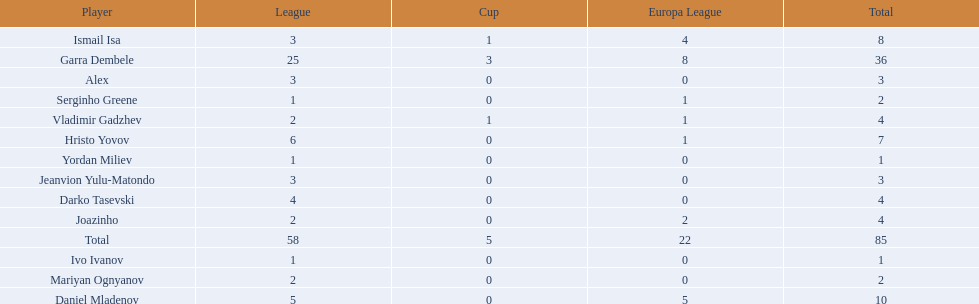What league is 2? 2, 2, 2. Which cup is less than 1? 0, 0. Which total is 2? 2. Who is the player? Mariyan Ognyanov. 